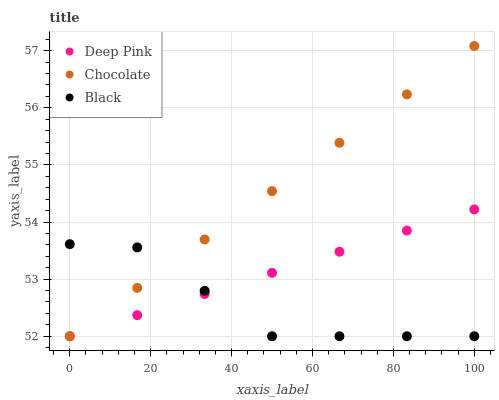Does Black have the minimum area under the curve?
Answer yes or no. Yes. Does Chocolate have the maximum area under the curve?
Answer yes or no. Yes. Does Chocolate have the minimum area under the curve?
Answer yes or no. No. Does Black have the maximum area under the curve?
Answer yes or no. No. Is Deep Pink the smoothest?
Answer yes or no. Yes. Is Black the roughest?
Answer yes or no. Yes. Is Chocolate the smoothest?
Answer yes or no. No. Is Chocolate the roughest?
Answer yes or no. No. Does Deep Pink have the lowest value?
Answer yes or no. Yes. Does Chocolate have the highest value?
Answer yes or no. Yes. Does Black have the highest value?
Answer yes or no. No. Does Chocolate intersect Black?
Answer yes or no. Yes. Is Chocolate less than Black?
Answer yes or no. No. Is Chocolate greater than Black?
Answer yes or no. No. 